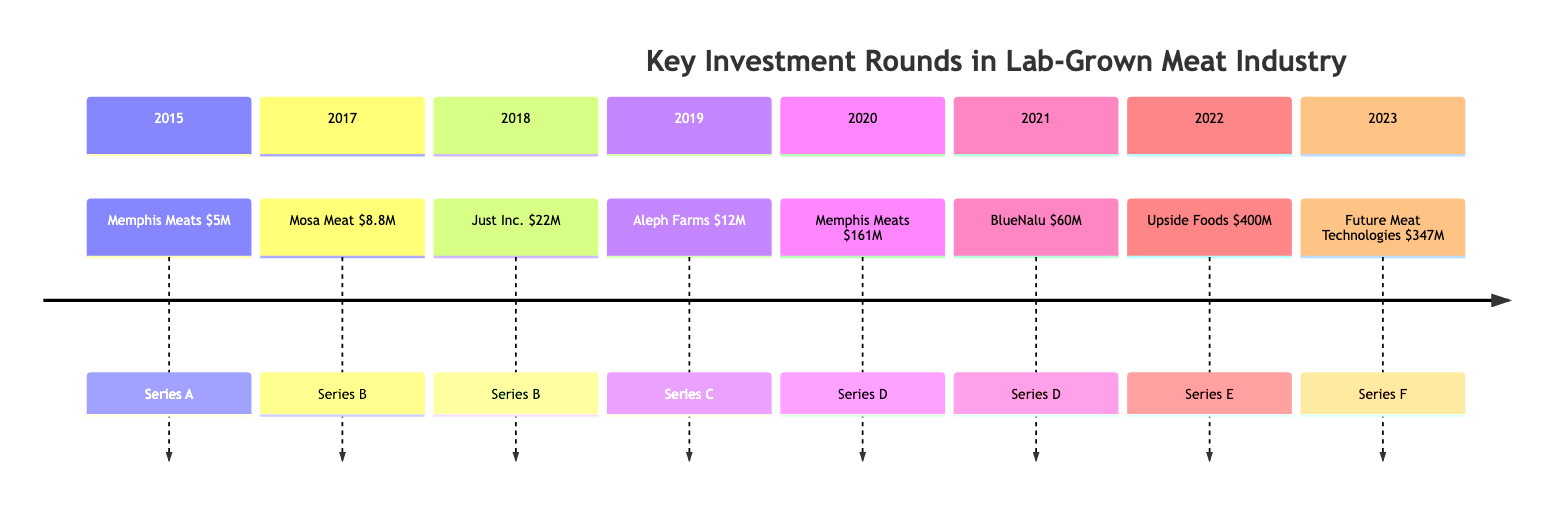What company received Series A funding in 2015? The diagram indicates that Memphis Meats is the company that received Series A funding in 2015.
Answer: Memphis Meats What was the total funding amount for Series D in 2021? In the timeline, it shows that BlueNalu received $60 million in Series D funding in 2021.
Answer: $60 million Which company had the highest funding amount in 2022? By examining the events of 2022, it is clear that Upside Foods received the highest funding amount at $400 million.
Answer: Upside Foods How many companies received Series B funding before 2020? From the timeline, there are two instances of Series B funding (Mosa Meat in 2017 and Just Inc. in 2018), which means two companies received Series B funding before 2020.
Answer: 2 What is the total funding amount from all the events listed? To find the total funding amount, we sum up the individual amounts: $5M + $8.8M + $22M + $12M + $161M + $60M + $400M + $347M = $1,016.8 million, which can also be expressed as $1.0168 billion.
Answer: $1.0168 billion Which year had the largest single funding event? By comparing all the funding amounts, the largest single funding event occurred in 2022 with Upside Foods receiving $400 million.
Answer: 2022 How many distinct funding rounds occurred in the timeline? The timeline shows a total of eight distinct funding rounds, ranging from Series A to Series F from 2015 to 2023.
Answer: 8 What was the amount raised by Memphis Meats in their Series D funding round? According to the timeline, Memphis Meats raised $161 million in their Series D funding round in 2020.
Answer: $161 million Which investors participated in funding for Just Inc. in 2018? The diagram lists Northgate Capital and Khosla Ventures as the key investors for Just Inc. in their Series B funding round in 2018.
Answer: Northgate Capital, Khosla Ventures 